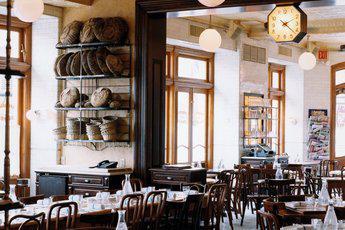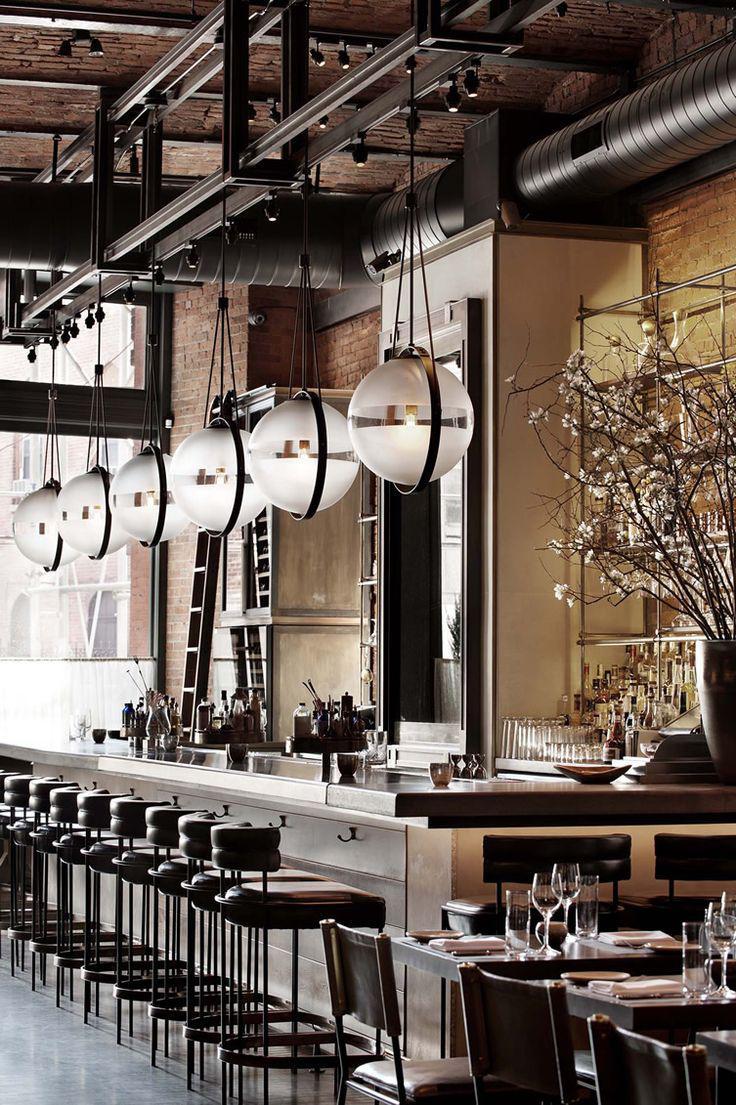The first image is the image on the left, the second image is the image on the right. Evaluate the accuracy of this statement regarding the images: "Each image contains restaurant employees". Is it true? Answer yes or no. No. The first image is the image on the left, the second image is the image on the right. Considering the images on both sides, is "People in white shirts are in front of and behind the long counter of an establishment with suspended glass lights in one image." valid? Answer yes or no. No. 